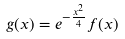Convert formula to latex. <formula><loc_0><loc_0><loc_500><loc_500>g ( x ) = e ^ { - \frac { x ^ { 2 } } { 4 } } f ( x )</formula> 